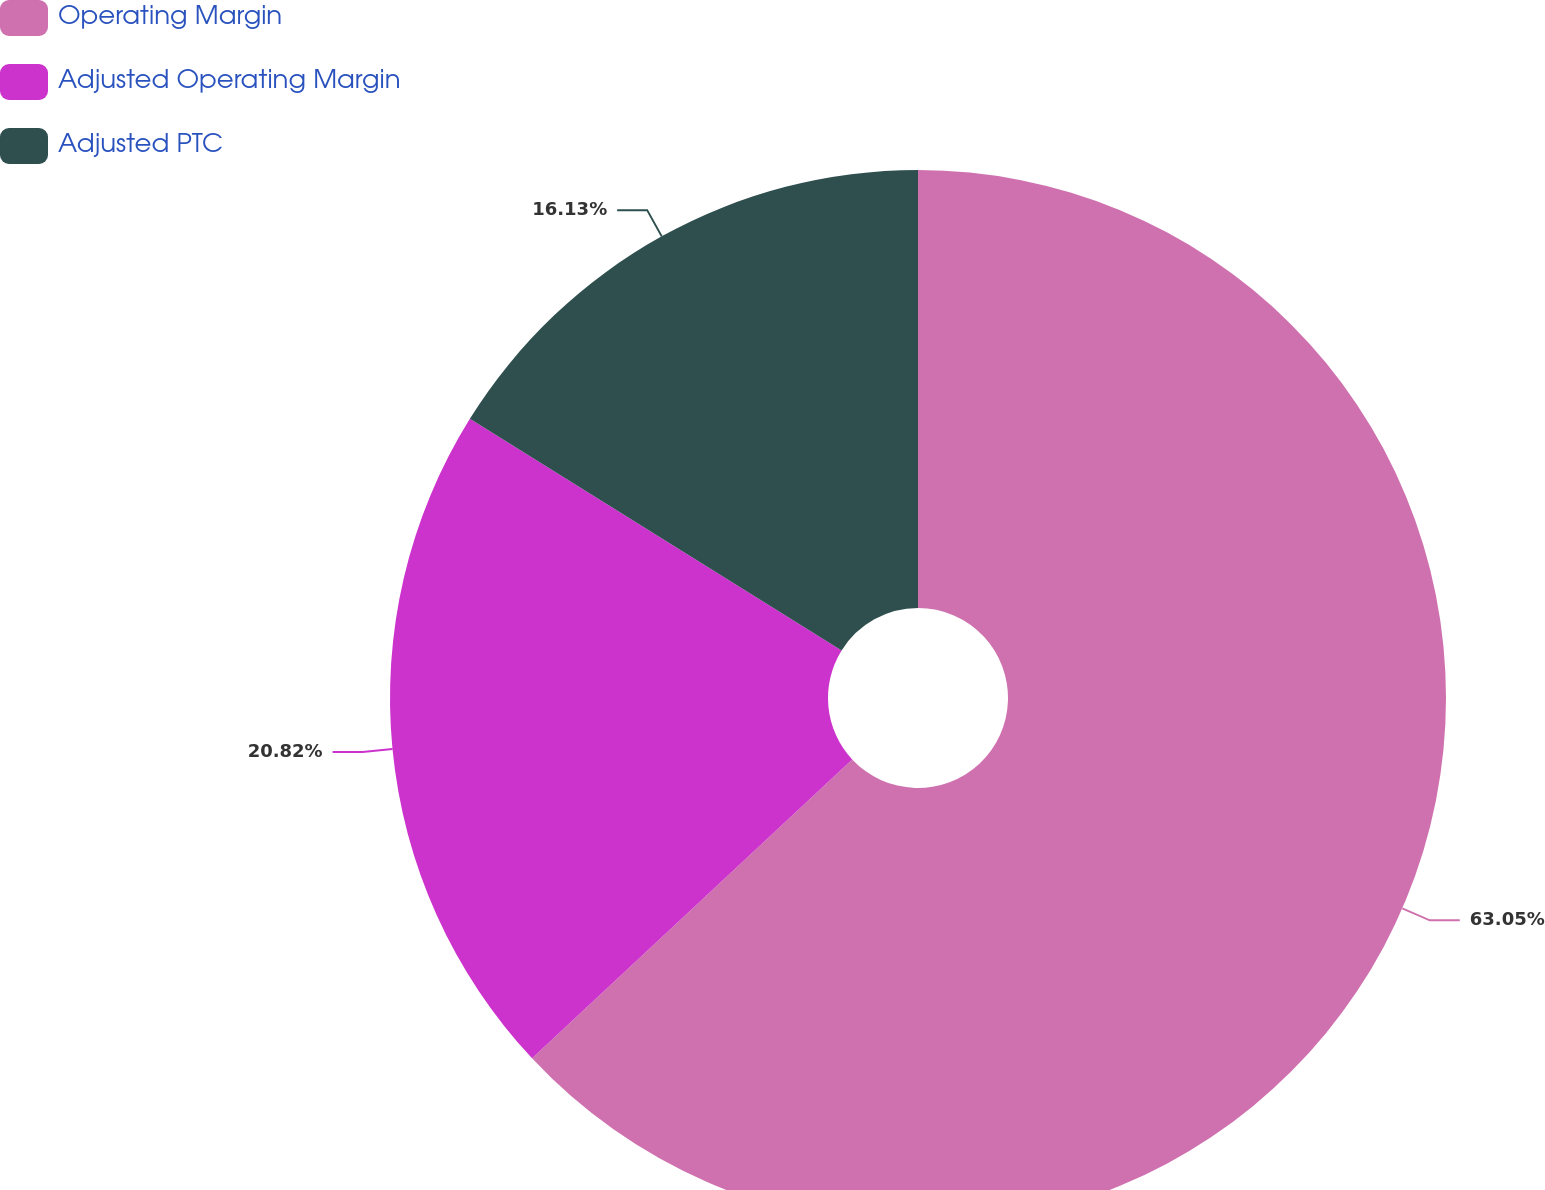Convert chart to OTSL. <chart><loc_0><loc_0><loc_500><loc_500><pie_chart><fcel>Operating Margin<fcel>Adjusted Operating Margin<fcel>Adjusted PTC<nl><fcel>63.04%<fcel>20.82%<fcel>16.13%<nl></chart> 